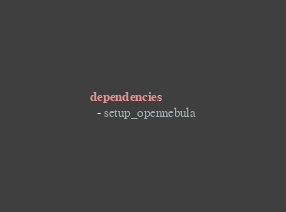Convert code to text. <code><loc_0><loc_0><loc_500><loc_500><_YAML_>dependencies:
  - setup_opennebula
</code> 